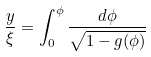Convert formula to latex. <formula><loc_0><loc_0><loc_500><loc_500>\frac { y } { \xi } = \int _ { 0 } ^ { \phi } \frac { d \phi } { \sqrt { 1 - g ( \phi ) } }</formula> 